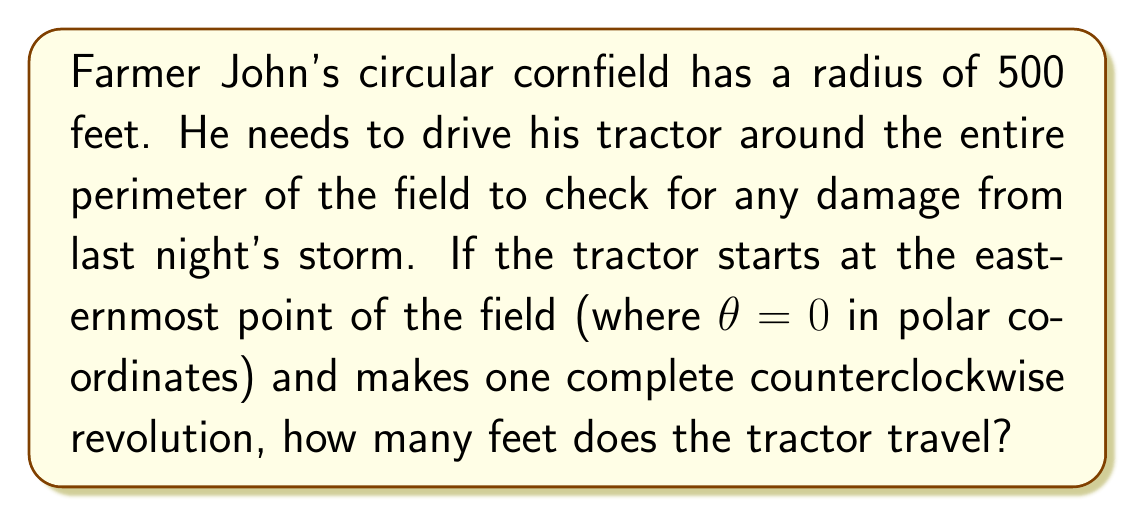Can you answer this question? To solve this problem, we need to understand that the tractor is traveling along the circumference of a circle. In polar coordinates, we can represent this path as $r = 500$ (constant radius) and $\theta$ varying from 0 to $2\pi$ radians (one complete revolution).

The distance traveled along a circular path in polar coordinates is given by the arc length formula:

$$s = r\theta$$

Where:
$s$ is the arc length (distance traveled)
$r$ is the radius of the circle
$\theta$ is the angle traversed in radians

In this case:
$r = 500$ feet
$\theta = 2\pi$ radians (one complete revolution)

Substituting these values into the formula:

$$s = 500 \cdot 2\pi$$

$$s = 1000\pi \text{ feet}$$

To get a decimal approximation:

$$s \approx 3141.59 \text{ feet}$$

This result makes sense because the circumference of a circle is given by $2\pi r$, which is exactly what we calculated.
Answer: The tractor travels $1000\pi$ feet (approximately 3141.59 feet). 